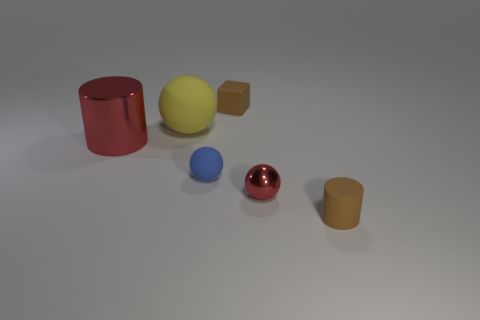Is the color of the matte cylinder the same as the small block?
Keep it short and to the point. Yes. What shape is the red metallic thing that is in front of the cylinder left of the small rubber thing that is behind the large red cylinder?
Offer a terse response. Sphere. What is the shape of the large yellow matte thing?
Make the answer very short. Sphere. What shape is the red thing that is the same size as the yellow object?
Provide a succinct answer. Cylinder. What number of other objects are the same color as the large ball?
Offer a terse response. 0. There is a red metallic thing that is to the right of the small blue thing; is it the same shape as the rubber thing to the left of the small blue rubber ball?
Offer a very short reply. Yes. How many objects are either cylinders in front of the tiny blue rubber object or small things that are behind the big ball?
Ensure brevity in your answer.  2. What number of other objects are there of the same material as the red cylinder?
Offer a terse response. 1. Do the brown object that is behind the small cylinder and the tiny red object have the same material?
Your answer should be compact. No. Is the number of small balls that are to the right of the tiny matte sphere greater than the number of big shiny cylinders that are right of the rubber cylinder?
Give a very brief answer. Yes. 